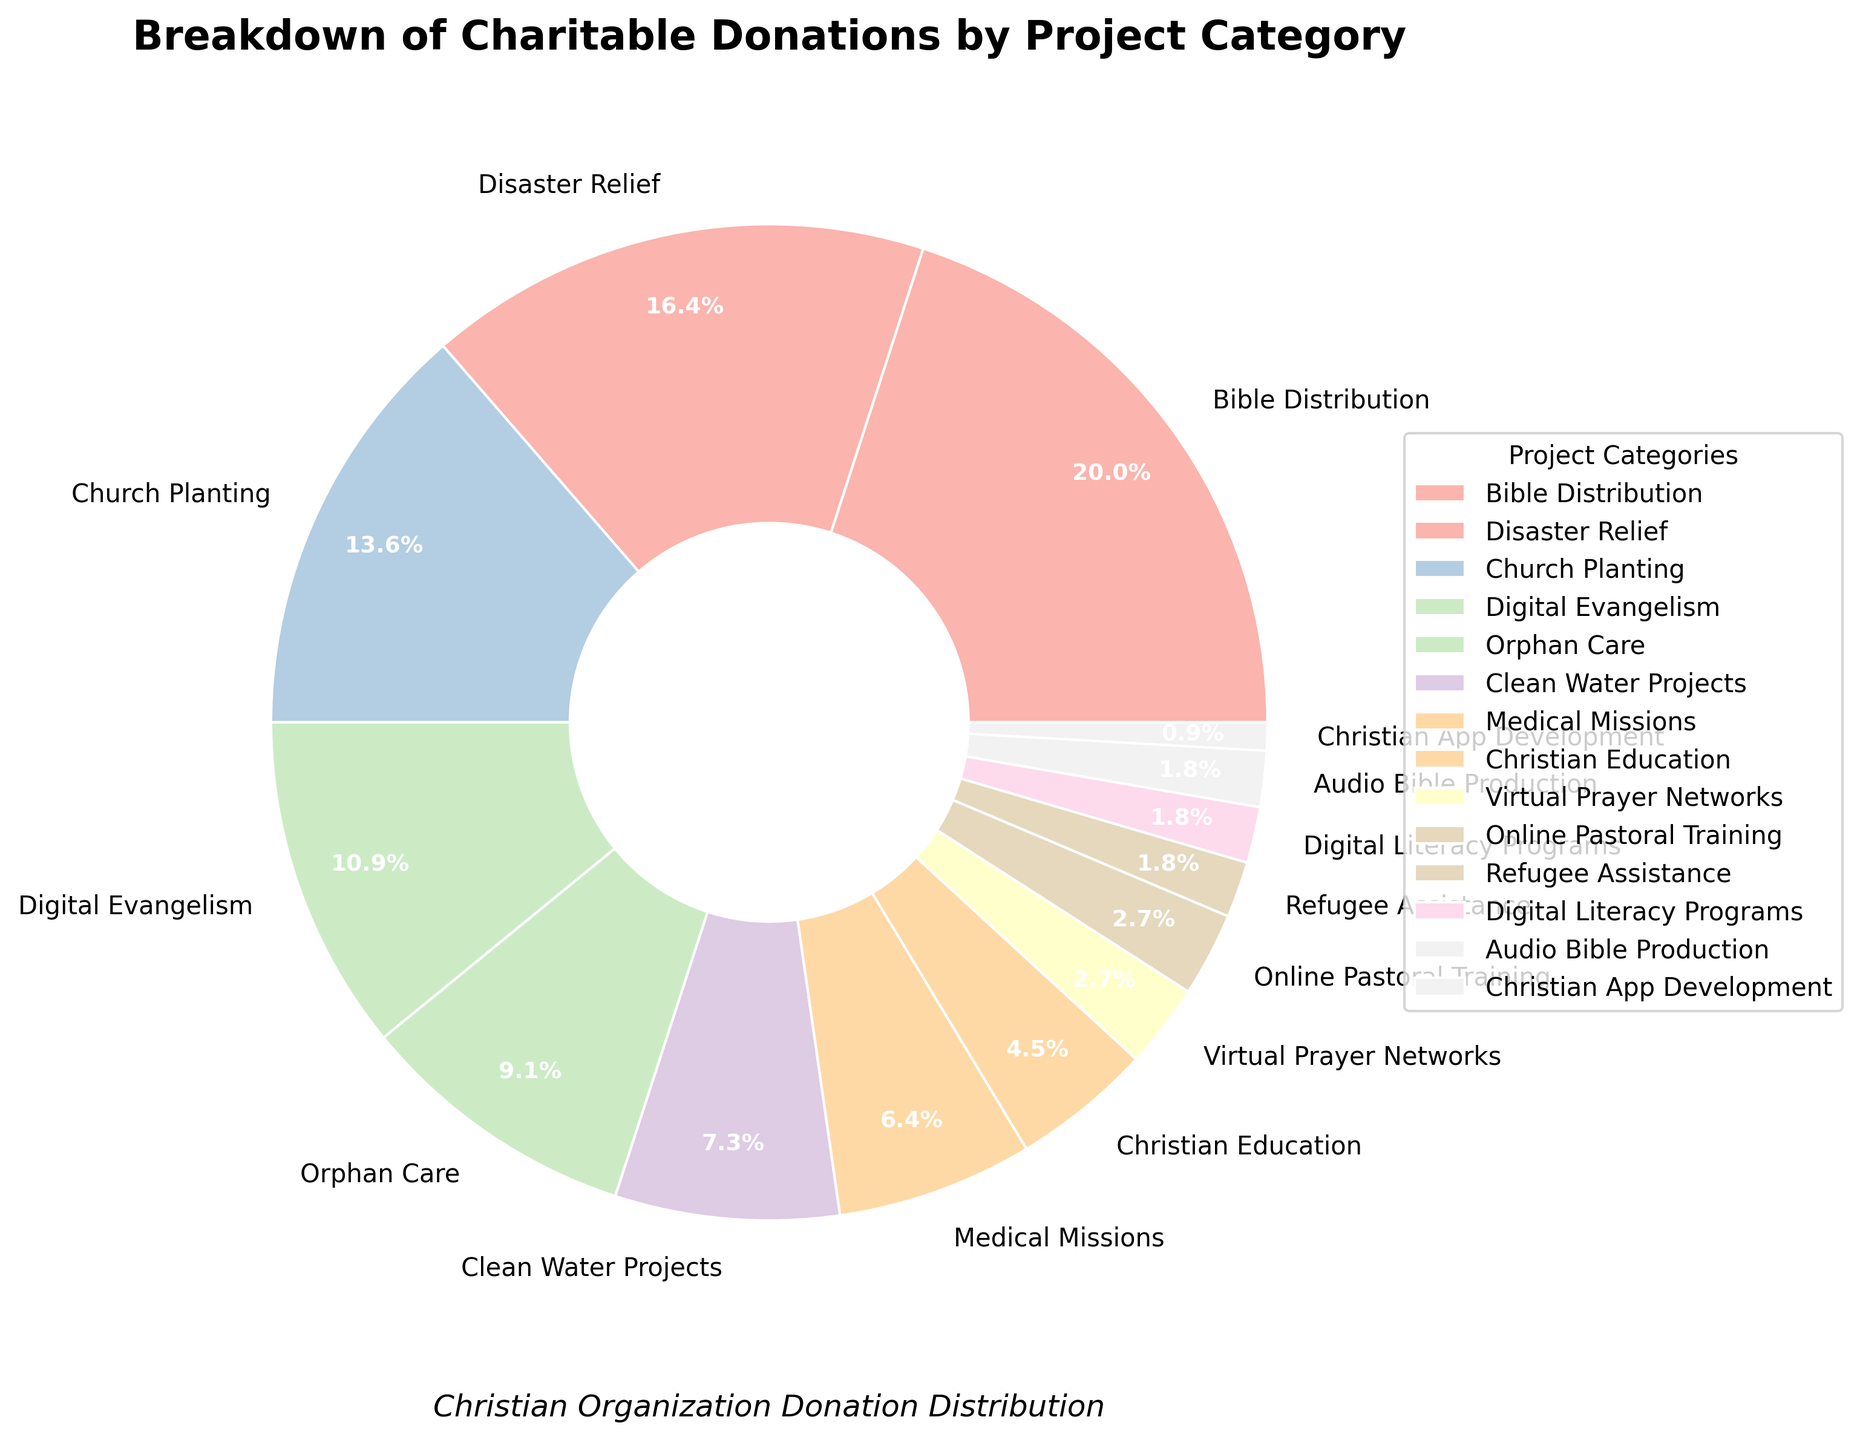What percentage of charitable donations is dedicated to digital-based projects? (Consider Digital Evangelism, Virtual Prayer Networks, Online Pastoral Training, Digital Literacy Programs, and Christian App Development) Sum the percentages of the digital-based projects: Digital Evangelism (12) + Virtual Prayer Networks (3) + Online Pastoral Training (3) + Digital Literacy Programs (2) + Christian App Development (1) = 21%
Answer: 21% Which project category received the highest percentage of donations? Look at the labels with percentages in the pie chart and identify the one with the highest value. Bible Distribution has 22%, which is the highest.
Answer: Bible Distribution How much more percentage of donations does Disaster Relief receive compared to Clean Water Projects? Disaster Relief has 18%, and Clean Water Projects has 8%. Calculate the difference: 18% - 8% = 10%
Answer: 10% Which two project categories have equal percentages of donations? Identify categories with the same percentage from the chart. Online Pastoral Training and Virtual Prayer Networks both have 3%.
Answer: Online Pastoral Training and Virtual Prayer Networks What is the combined percentage of donations for Bible Distribution, Church Planting, and Christian Education? Sum the percentages of the three categories: Bible Distribution (22) + Church Planting (15) + Christian Education (5) = 42%
Answer: 42% Compare the percentages of donations for Orphan Care and Medical Missions. Which one is higher and by how much? Orphan Care has 10%, and Medical Missions has 7%. Calculate the difference: 10% - 7% = 3%. Orphan Care is higher.
Answer: Orphan Care by 3% How does the percentage of donations for Audio Bible Production compare to that for Refugee Assistance? Look at the percentages for both categories, which are 2% each.
Answer: They are equal What is the average donation percentage for the categories with the smallest donations? (Consider categories with 2% or less) Add the percentages of Audio Bible Production (2), Refugee Assistance (2), and Christian App Development (1). Then divide by the number of categories: (2 + 2 + 1)/3 = 5/3 ≈ 1.67%
Answer: 1.67% Which categories fall below the 5% donation threshold? Identify categories with percentages less than 5%. Christian Education (5) does not count as below, so categories are Virtual Prayer Networks (3), Online Pastoral Training (3), Refugee Assistance (2), Digital Literacy Programs (2), Audio Bible Production (2), and Christian App Development (1).
Answer: Virtual Prayer Networks, Online Pastoral Training, Refugee Assistance, Digital Literacy Programs, Audio Bible Production, Christian App Development If we were to redistribute 2% from Bible Distribution to Refugee Assistance, what would be their new percentages? Subtract 2% from Bible Distribution (22% - 2% = 20%) and add it to Refugee Assistance (2% + 2% = 4%).
Answer: Bible Distribution: 20%, Refugee Assistance: 4% 